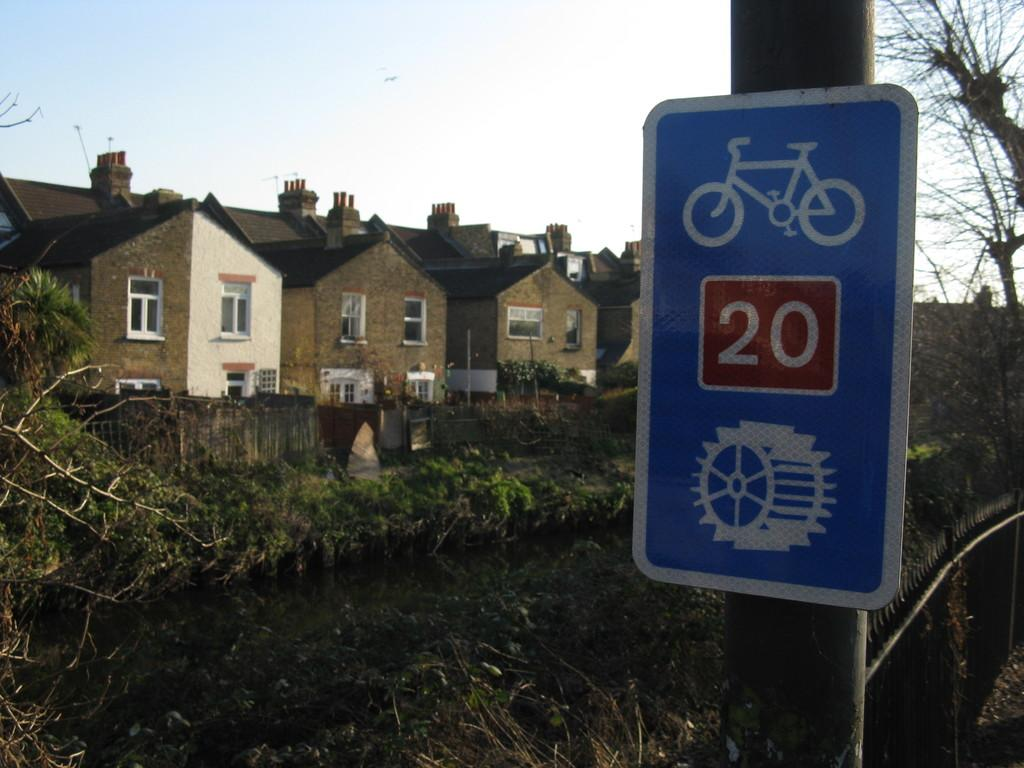<image>
Create a compact narrative representing the image presented. a blue sign with a bike at mile marker 20 